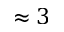<formula> <loc_0><loc_0><loc_500><loc_500>\approx 3</formula> 